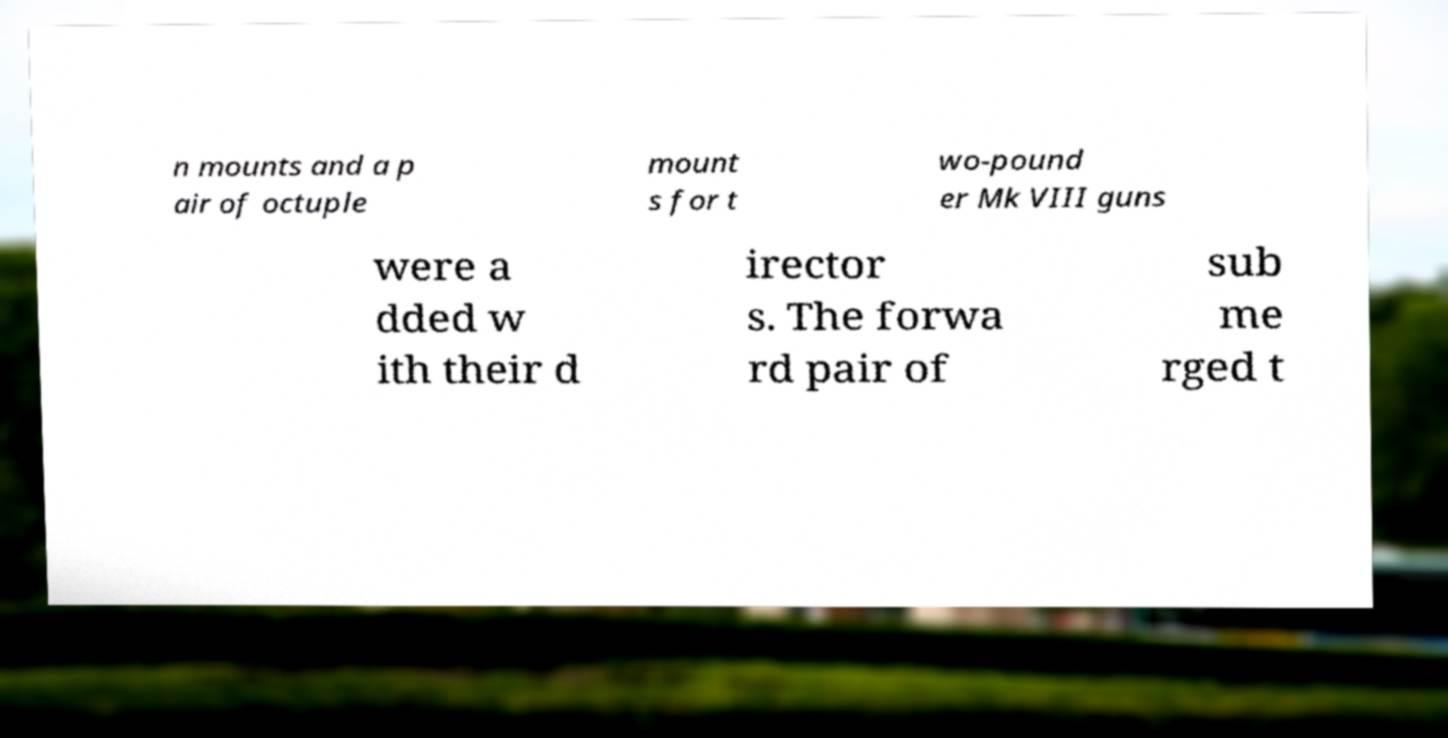Please identify and transcribe the text found in this image. n mounts and a p air of octuple mount s for t wo-pound er Mk VIII guns were a dded w ith their d irector s. The forwa rd pair of sub me rged t 